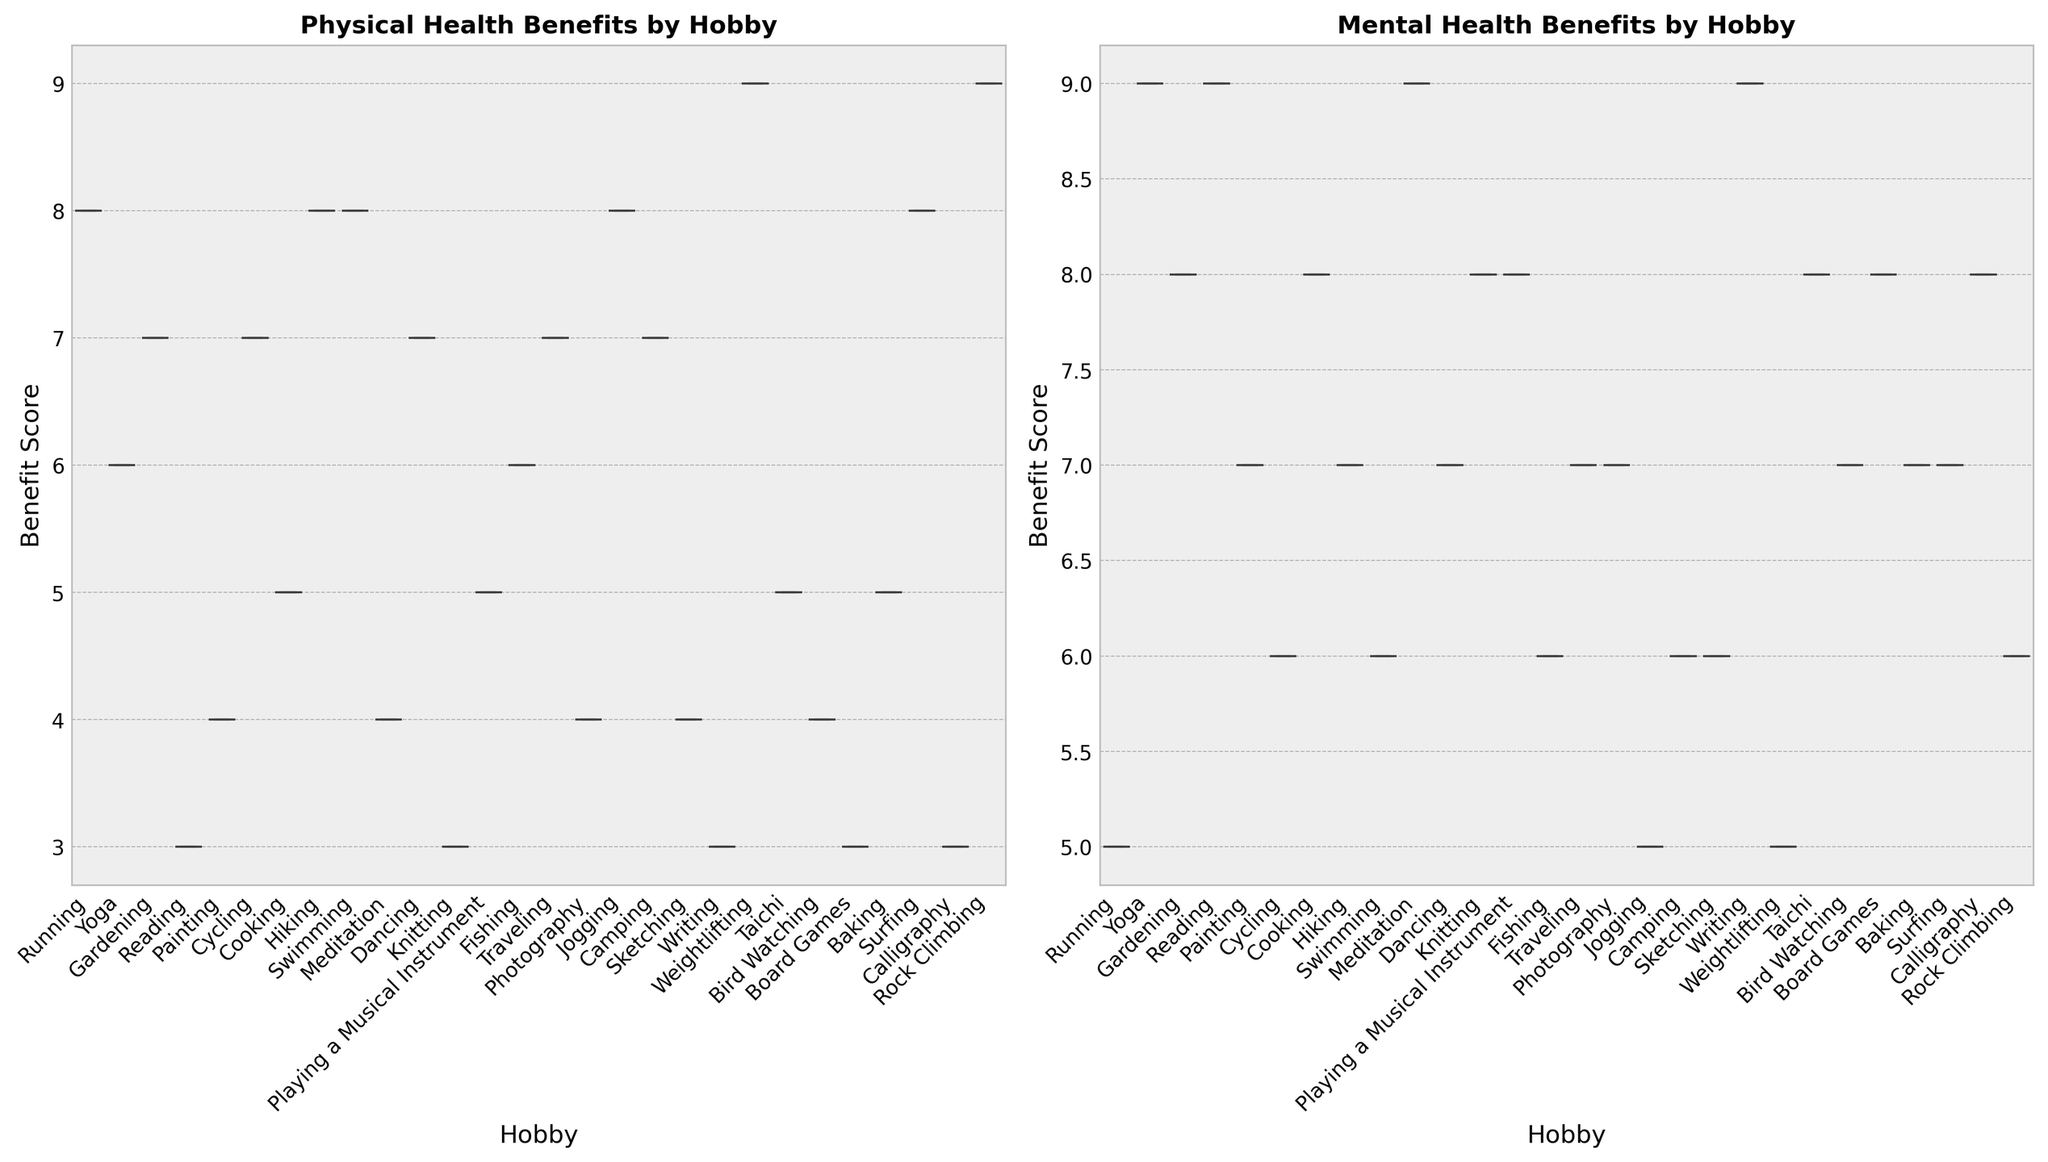Which hobby has the highest median physical health benefit score? To find the hobby with the highest median physical health benefit score, look at the central line within each boxplot for the physical health benefits. Identify the hobby with the highest position of this median line.
Answer: Weightlifting Which hobby has the highest median mental health benefit score? To determine the hobby with the highest median mental health benefit score, check the central line of each boxplot for mental health benefits and find the highest line across the hobbies.
Answer: Reading Is the median mental health benefit score for Yoga higher than for Running? Compare the central line within the boxplot for Yoga and Running under the mental health benefits. The line for Yoga is clearly above that for Running.
Answer: Yes What is the range of the physical health benefit scores for Painting? The range is the difference between the upper and lower whiskers in Painting’s boxplot for physical health. Here, identify the highest value (top whisker) and the lowest value (bottom whisker) and subtract the lowest from the highest.
Answer: 4 (Range is from 4 to 8) Which hobby shows the largest interquartile range (IQR) for physical health benefits? The IQR is the difference between the upper quartile (top of the box) and the lower quartile (bottom of the box). Observe the box heights of each hobby’s boxplot under physical health benefits and identify the longest box.
Answer: Painting and Running (IQR of 4) Are the physical and mental health benefit scores for Swimming equal in terms of median values? Compare the central lines within the Swimming boxplots for physical and mental health benefits. Both have the same median line.
Answer: Yes Which hobby has a higher maximum score for mental health benefits, Gardening or Bird Watching? Identify the top whiskers for the mental health benefits of Gardening and Bird Watching. The one with the higher position represents the higher maximum score.
Answer: Gardening Do physical health benefit scores generally show more dispersion than mental health benefit scores across hobbies? Compare the lengths of the boxes and whiskers in the boxplots of physical health benefits with those of mental health benefits. Longer boxes and whiskers indicate more dispersion.
Answer: Yes Which hobby related to 'Mindfulness' has the lowest minimum value for physical health benefit scores? Identify the hobbies under 'Mindfulness' and find the boxplot with the lowest bottom whisker for physical health benefits.
Answer: Meditation Is the third quartile (75th percentile) of the physical health benefit scores for Jogging higher than the median of physical health benefit scores for Cycling? Compare the top of the Jogging box (third quartile) with the central line of the Cycling box (median) for physical health benefit scores.
Answer: Yes 